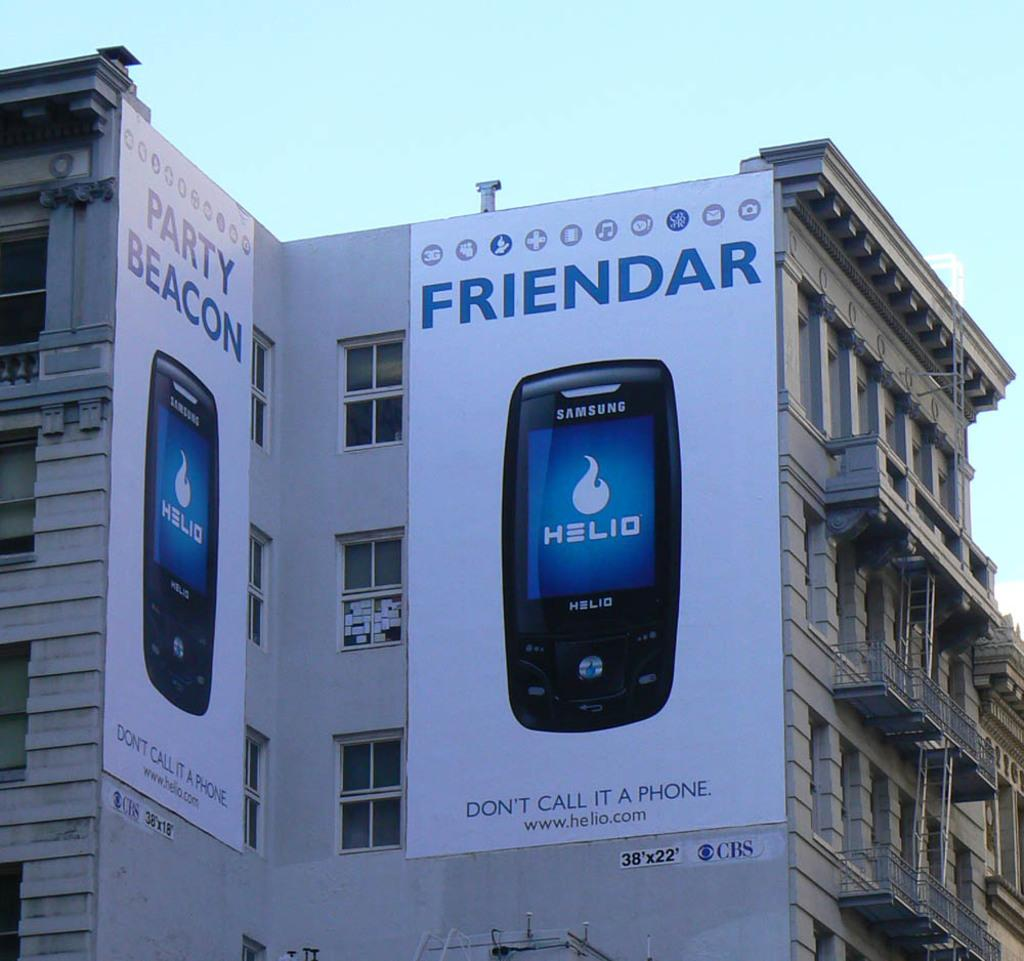<image>
Offer a succinct explanation of the picture presented. a bilboard for the Samsung cell phone HELIO with the words FRIENDAR in blue adorn two sides of a building 